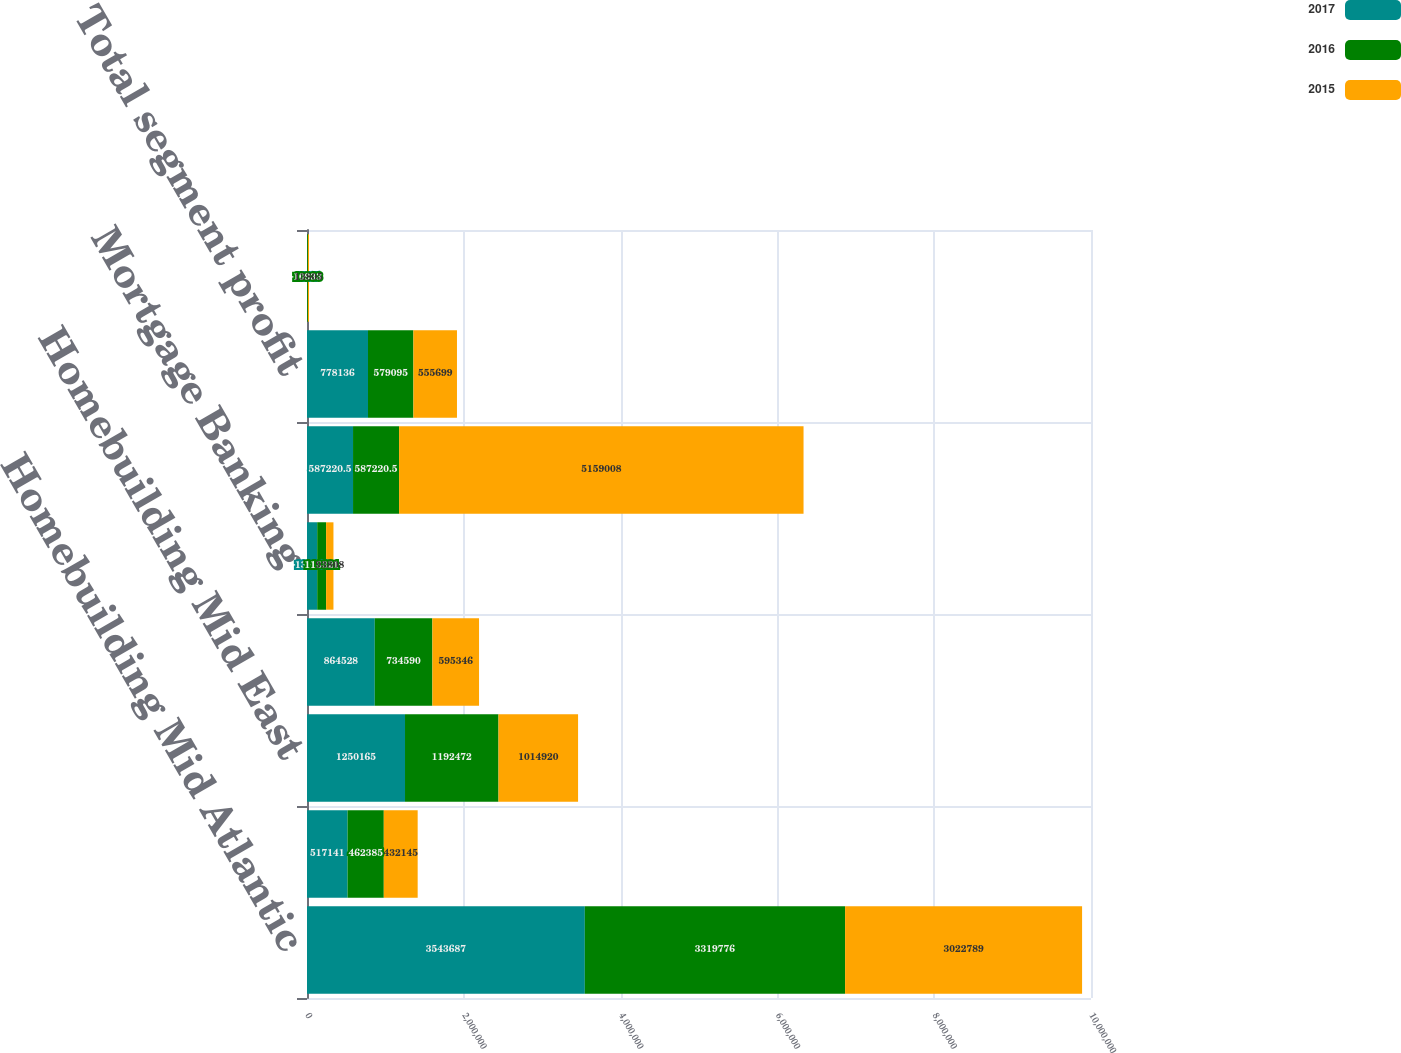Convert chart. <chart><loc_0><loc_0><loc_500><loc_500><stacked_bar_chart><ecel><fcel>Homebuilding Mid Atlantic<fcel>Homebuilding North East<fcel>Homebuilding Mid East<fcel>Homebuilding South East<fcel>Mortgage Banking<fcel>Consolidated revenues<fcel>Total segment profit<fcel>Contract land deposit reserve<nl><fcel>2017<fcel>3.54369e+06<fcel>517141<fcel>1.25016e+06<fcel>864528<fcel>130319<fcel>587220<fcel>778136<fcel>1307<nl><fcel>2016<fcel>3.31978e+06<fcel>462385<fcel>1.19247e+06<fcel>734590<fcel>113321<fcel>587220<fcel>579095<fcel>10933<nl><fcel>2015<fcel>3.02279e+06<fcel>432145<fcel>1.01492e+06<fcel>595346<fcel>93808<fcel>5.15901e+06<fcel>555699<fcel>13805<nl></chart> 